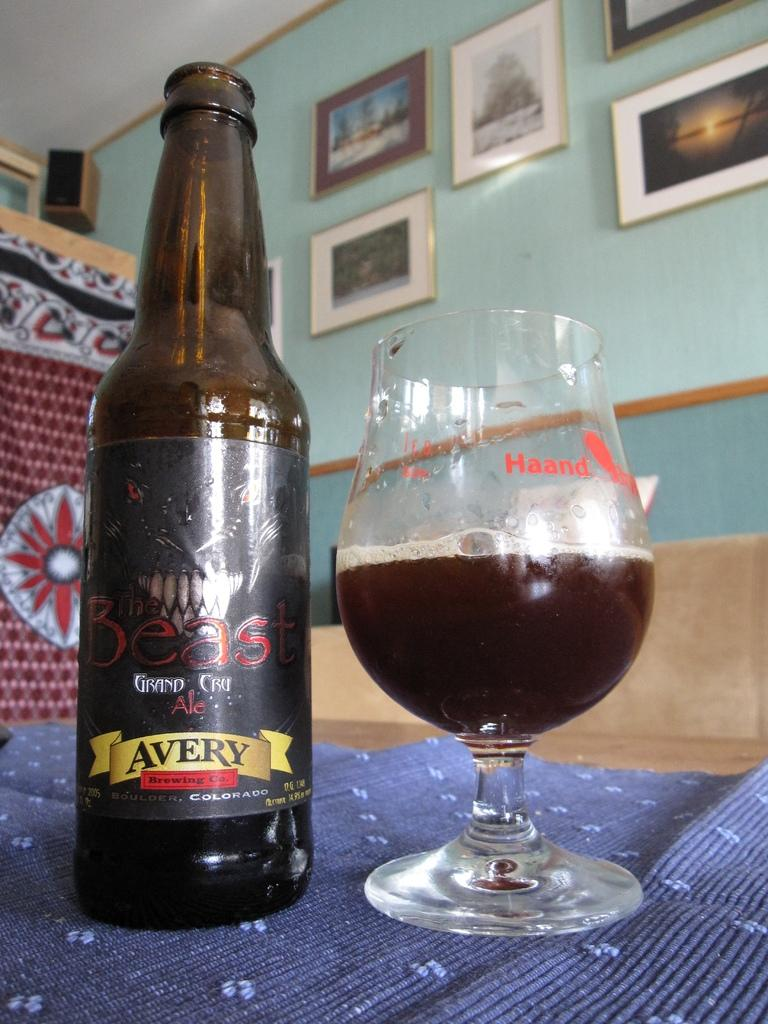What type of glass is visible in the image? There is a wine glass in the image. What is the wine glass likely to contain? The wine glass is likely to contain wine, as there is a wine bottle in the image. Where are the wine glass and bottle located? Both the wine glass and bottle are on a table. What can be seen on the wall in the image? There are photo frames on the wall. What type of device is visible in the top left corner of the image? There is a speaker in the top left corner of the image. How much fuel is needed to power the popcorn machine in the image? There is no popcorn machine present in the image, so it is not possible to determine how much fuel is needed. 